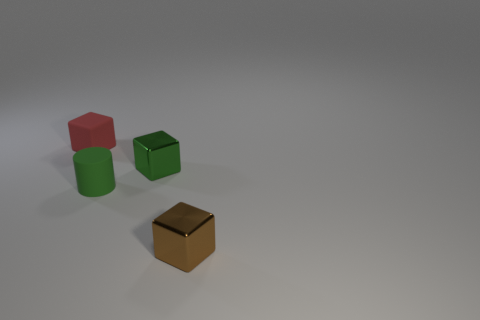Add 4 purple balls. How many objects exist? 8 Subtract all blocks. How many objects are left? 1 Subtract 0 yellow spheres. How many objects are left? 4 Subtract all green matte things. Subtract all red metallic cylinders. How many objects are left? 3 Add 4 rubber cylinders. How many rubber cylinders are left? 5 Add 1 small brown metallic cubes. How many small brown metallic cubes exist? 2 